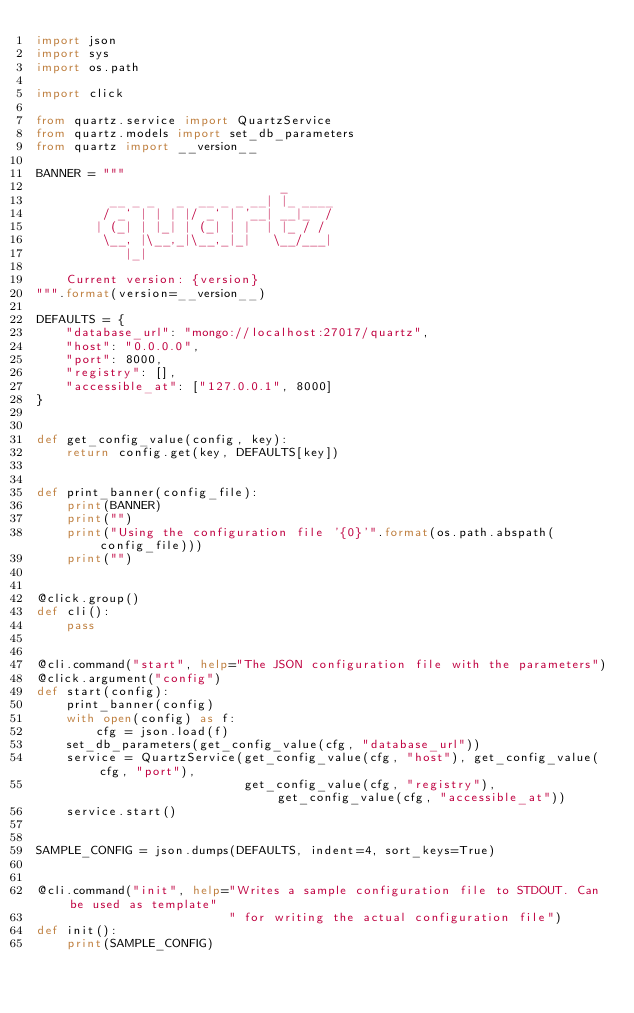<code> <loc_0><loc_0><loc_500><loc_500><_Python_>import json
import sys
import os.path

import click

from quartz.service import QuartzService
from quartz.models import set_db_parameters
from quartz import __version__

BANNER = """
                                 _
          __ _ _   _  __ _ _ __| |_ ____
         / _` | | | |/ _` | '__| __|_  /
        | (_| | |_| | (_| | |  | |_ / /
         \__, |\__,_|\__,_|_|   \__/___|
            |_|

    Current version: {version}
""".format(version=__version__)

DEFAULTS = {
    "database_url": "mongo://localhost:27017/quartz",
    "host": "0.0.0.0",
    "port": 8000,
    "registry": [],
    "accessible_at": ["127.0.0.1", 8000]
}


def get_config_value(config, key):
    return config.get(key, DEFAULTS[key])


def print_banner(config_file):
    print(BANNER)
    print("")
    print("Using the configuration file '{0}'".format(os.path.abspath(config_file)))
    print("")


@click.group()
def cli():
    pass


@cli.command("start", help="The JSON configuration file with the parameters")
@click.argument("config")
def start(config):
    print_banner(config)
    with open(config) as f:
        cfg = json.load(f)
    set_db_parameters(get_config_value(cfg, "database_url"))
    service = QuartzService(get_config_value(cfg, "host"), get_config_value(cfg, "port"),
                            get_config_value(cfg, "registry"), get_config_value(cfg, "accessible_at"))
    service.start()


SAMPLE_CONFIG = json.dumps(DEFAULTS, indent=4, sort_keys=True)


@cli.command("init", help="Writes a sample configuration file to STDOUT. Can be used as template"
                          " for writing the actual configuration file")
def init():
    print(SAMPLE_CONFIG)
</code> 